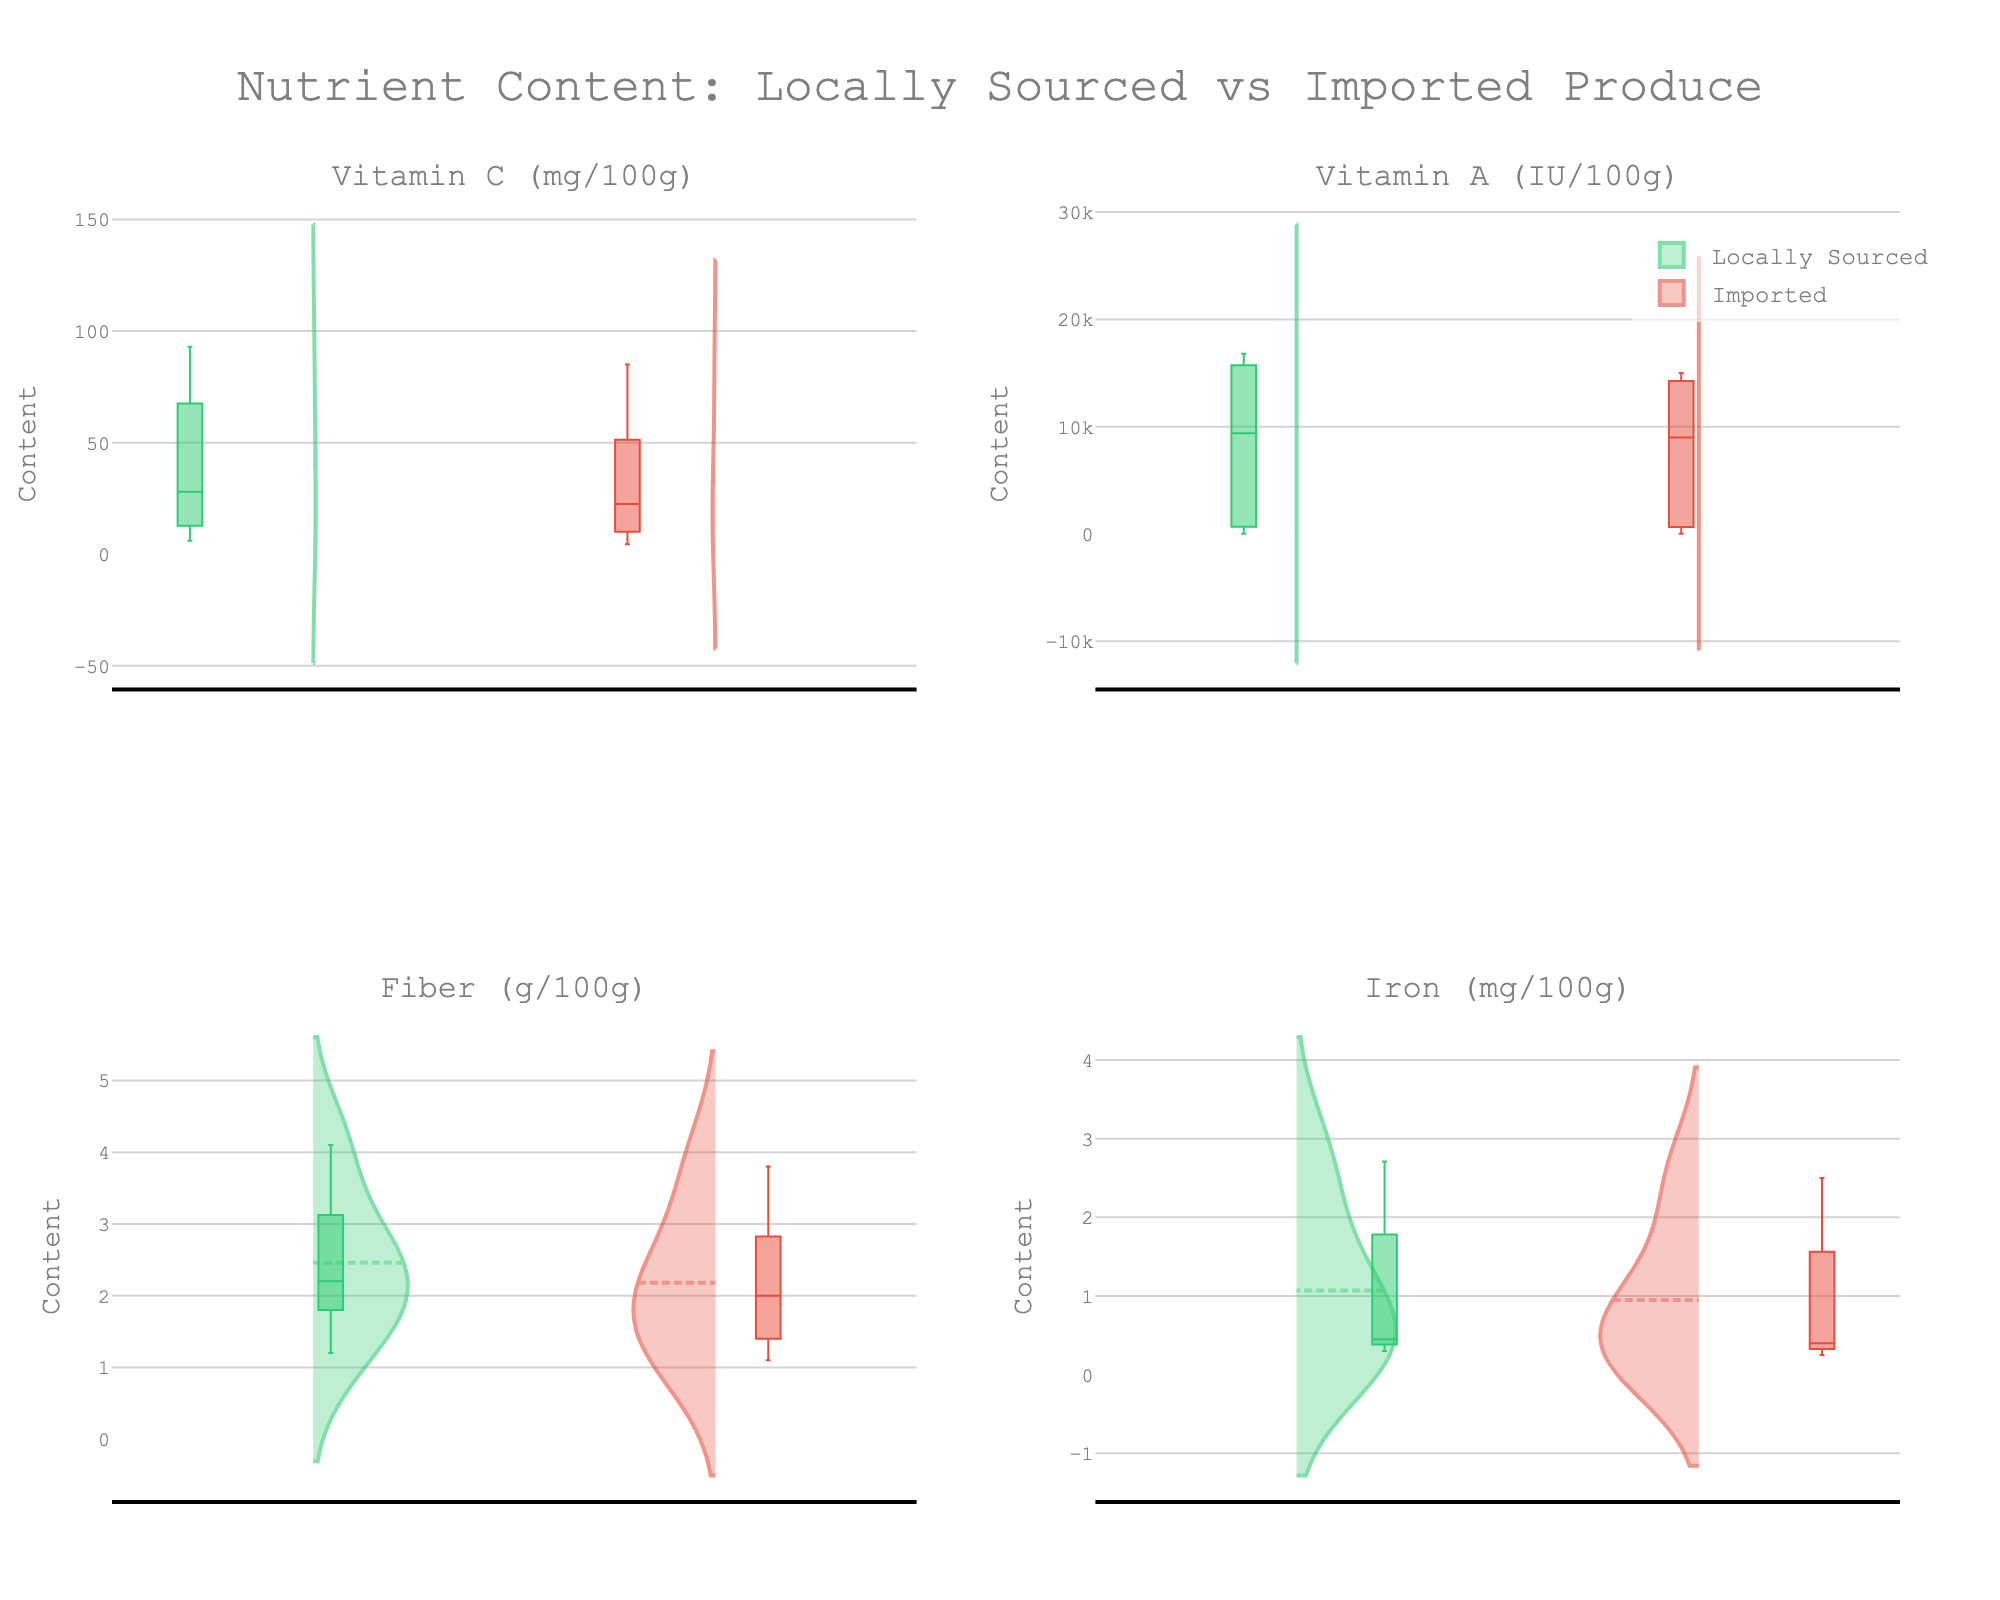What is the title of the figure? The title is typically displayed at the top center of the figure. In this case, it should read "Nutrient Content: Locally Sourced vs Imported Produce".
Answer: Nutrient Content: Locally Sourced vs Imported Produce How many different types of produce are analyzed in the figure? The number of different types of produce can be found by counting the distinct names in the data. In this dataset, we have Tomato, Spinach, Carrot, Strawberry, and Kale.
Answer: 5 Which nutrient has the highest content in Locally Sourced produce? The four nutrients are Vitamin C, Vitamin A, Fiber, and Iron. By looking at the nutrient distributions, Vitamin A in kale has the highest value when locally sourced.
Answer: Vitamin A For which vegetable is the difference in Vitamin C content between Locally Sourced and Imported the greatest? By comparing the Vitamin C values for each vegetable, Strawberry has the greatest difference (59.0 mg - 40.0 mg = 19.0 mg).
Answer: Strawberry Do Locally Sourced or Imported produce tend to have higher Fiber content overall? By comparing the violin plots for Fiber content, it appears that Locally Sourced produce generally have higher Fiber values than Imported produce.
Answer: Locally Sourced Which produce has the smallest variance in Iron content? Variance can be assessed by the spread of the box plots within the violin charts. Tomatoes have the smallest variance in Iron content since their box plot is narrow and contained.
Answer: Tomato What is the median Iron content for Locally Sourced Spinach? The median value in a box plot is indicated by the line inside the box. For Locally Sourced Spinach, this median value in the plot corresponds to approximately 2.71 mg.
Answer: 2.71 mg Between Locally Sourced and Imported Kale, which has a higher variability in Vitamin C content? Variability can be assessed by the width of the violin plots and the spread of the box plots. Locally Sourced Kale has a wider spread compared to Imported Kale, indicating higher variability.
Answer: Locally Sourced How do the ranges of Vitamin A content compare between Locally Sourced and Imported Carrot? The range can be determined by the spread of the box plots. Locally Sourced Carrot has broader interquartile ranges compared to Imported Carrot, indicating higher spread in the data.
Answer: Locally Sourced Which nutrient shows the smallest difference in median values between Locally Sourced and Imported produce? By comparing the median lines in the box plots across the four nutrients, the smallest difference in median values between Locally Sourced and Imported produce is found in Fiber content.
Answer: Fiber 